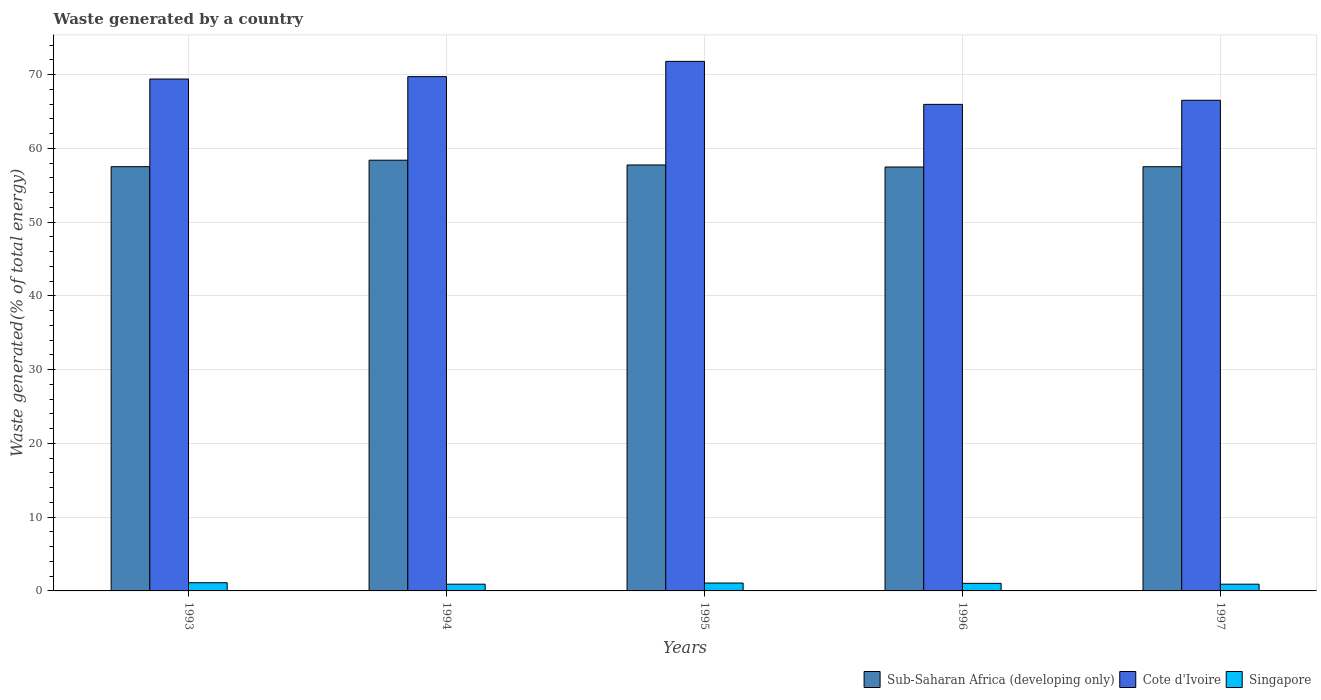How many different coloured bars are there?
Provide a succinct answer. 3. Are the number of bars per tick equal to the number of legend labels?
Offer a terse response. Yes. Are the number of bars on each tick of the X-axis equal?
Provide a succinct answer. Yes. In how many cases, is the number of bars for a given year not equal to the number of legend labels?
Offer a terse response. 0. What is the total waste generated in Singapore in 1997?
Provide a succinct answer. 0.91. Across all years, what is the maximum total waste generated in Sub-Saharan Africa (developing only)?
Offer a terse response. 58.41. Across all years, what is the minimum total waste generated in Singapore?
Your answer should be very brief. 0.91. In which year was the total waste generated in Sub-Saharan Africa (developing only) maximum?
Your response must be concise. 1994. What is the total total waste generated in Sub-Saharan Africa (developing only) in the graph?
Provide a succinct answer. 288.73. What is the difference between the total waste generated in Sub-Saharan Africa (developing only) in 1995 and that in 1996?
Your response must be concise. 0.28. What is the difference between the total waste generated in Cote d'Ivoire in 1993 and the total waste generated in Singapore in 1994?
Ensure brevity in your answer.  68.51. What is the average total waste generated in Sub-Saharan Africa (developing only) per year?
Provide a short and direct response. 57.75. In the year 1995, what is the difference between the total waste generated in Singapore and total waste generated in Cote d'Ivoire?
Your answer should be very brief. -70.74. What is the ratio of the total waste generated in Cote d'Ivoire in 1994 to that in 1997?
Make the answer very short. 1.05. Is the total waste generated in Singapore in 1993 less than that in 1994?
Provide a succinct answer. No. Is the difference between the total waste generated in Singapore in 1995 and 1996 greater than the difference between the total waste generated in Cote d'Ivoire in 1995 and 1996?
Keep it short and to the point. No. What is the difference between the highest and the second highest total waste generated in Singapore?
Your answer should be compact. 0.04. What is the difference between the highest and the lowest total waste generated in Sub-Saharan Africa (developing only)?
Your answer should be very brief. 0.92. In how many years, is the total waste generated in Singapore greater than the average total waste generated in Singapore taken over all years?
Keep it short and to the point. 3. What does the 1st bar from the left in 1994 represents?
Offer a terse response. Sub-Saharan Africa (developing only). What does the 2nd bar from the right in 1993 represents?
Give a very brief answer. Cote d'Ivoire. Are all the bars in the graph horizontal?
Offer a terse response. No. How many years are there in the graph?
Your response must be concise. 5. Are the values on the major ticks of Y-axis written in scientific E-notation?
Make the answer very short. No. Does the graph contain any zero values?
Provide a short and direct response. No. How many legend labels are there?
Make the answer very short. 3. How are the legend labels stacked?
Ensure brevity in your answer.  Horizontal. What is the title of the graph?
Offer a very short reply. Waste generated by a country. What is the label or title of the Y-axis?
Ensure brevity in your answer.  Waste generated(% of total energy). What is the Waste generated(% of total energy) in Sub-Saharan Africa (developing only) in 1993?
Offer a terse response. 57.53. What is the Waste generated(% of total energy) of Cote d'Ivoire in 1993?
Provide a short and direct response. 69.42. What is the Waste generated(% of total energy) in Singapore in 1993?
Your answer should be compact. 1.11. What is the Waste generated(% of total energy) in Sub-Saharan Africa (developing only) in 1994?
Give a very brief answer. 58.41. What is the Waste generated(% of total energy) in Cote d'Ivoire in 1994?
Your answer should be compact. 69.75. What is the Waste generated(% of total energy) of Singapore in 1994?
Ensure brevity in your answer.  0.91. What is the Waste generated(% of total energy) in Sub-Saharan Africa (developing only) in 1995?
Give a very brief answer. 57.77. What is the Waste generated(% of total energy) of Cote d'Ivoire in 1995?
Your answer should be compact. 71.82. What is the Waste generated(% of total energy) in Singapore in 1995?
Your response must be concise. 1.07. What is the Waste generated(% of total energy) in Sub-Saharan Africa (developing only) in 1996?
Your answer should be compact. 57.49. What is the Waste generated(% of total energy) of Cote d'Ivoire in 1996?
Offer a very short reply. 65.98. What is the Waste generated(% of total energy) of Singapore in 1996?
Give a very brief answer. 1.03. What is the Waste generated(% of total energy) of Sub-Saharan Africa (developing only) in 1997?
Offer a terse response. 57.53. What is the Waste generated(% of total energy) of Cote d'Ivoire in 1997?
Keep it short and to the point. 66.54. What is the Waste generated(% of total energy) in Singapore in 1997?
Make the answer very short. 0.91. Across all years, what is the maximum Waste generated(% of total energy) of Sub-Saharan Africa (developing only)?
Ensure brevity in your answer.  58.41. Across all years, what is the maximum Waste generated(% of total energy) of Cote d'Ivoire?
Ensure brevity in your answer.  71.82. Across all years, what is the maximum Waste generated(% of total energy) in Singapore?
Provide a short and direct response. 1.11. Across all years, what is the minimum Waste generated(% of total energy) of Sub-Saharan Africa (developing only)?
Provide a short and direct response. 57.49. Across all years, what is the minimum Waste generated(% of total energy) in Cote d'Ivoire?
Your answer should be compact. 65.98. Across all years, what is the minimum Waste generated(% of total energy) in Singapore?
Make the answer very short. 0.91. What is the total Waste generated(% of total energy) of Sub-Saharan Africa (developing only) in the graph?
Your answer should be very brief. 288.73. What is the total Waste generated(% of total energy) in Cote d'Ivoire in the graph?
Your answer should be very brief. 343.51. What is the total Waste generated(% of total energy) in Singapore in the graph?
Provide a short and direct response. 5.04. What is the difference between the Waste generated(% of total energy) in Sub-Saharan Africa (developing only) in 1993 and that in 1994?
Your answer should be compact. -0.88. What is the difference between the Waste generated(% of total energy) in Cote d'Ivoire in 1993 and that in 1994?
Provide a short and direct response. -0.33. What is the difference between the Waste generated(% of total energy) of Singapore in 1993 and that in 1994?
Provide a succinct answer. 0.2. What is the difference between the Waste generated(% of total energy) in Sub-Saharan Africa (developing only) in 1993 and that in 1995?
Keep it short and to the point. -0.23. What is the difference between the Waste generated(% of total energy) in Cote d'Ivoire in 1993 and that in 1995?
Offer a very short reply. -2.4. What is the difference between the Waste generated(% of total energy) of Singapore in 1993 and that in 1995?
Your response must be concise. 0.04. What is the difference between the Waste generated(% of total energy) in Sub-Saharan Africa (developing only) in 1993 and that in 1996?
Your answer should be very brief. 0.05. What is the difference between the Waste generated(% of total energy) of Cote d'Ivoire in 1993 and that in 1996?
Your answer should be compact. 3.44. What is the difference between the Waste generated(% of total energy) in Singapore in 1993 and that in 1996?
Ensure brevity in your answer.  0.08. What is the difference between the Waste generated(% of total energy) in Sub-Saharan Africa (developing only) in 1993 and that in 1997?
Offer a terse response. 0.01. What is the difference between the Waste generated(% of total energy) of Cote d'Ivoire in 1993 and that in 1997?
Provide a succinct answer. 2.88. What is the difference between the Waste generated(% of total energy) in Singapore in 1993 and that in 1997?
Provide a succinct answer. 0.2. What is the difference between the Waste generated(% of total energy) in Sub-Saharan Africa (developing only) in 1994 and that in 1995?
Keep it short and to the point. 0.65. What is the difference between the Waste generated(% of total energy) in Cote d'Ivoire in 1994 and that in 1995?
Provide a succinct answer. -2.07. What is the difference between the Waste generated(% of total energy) in Singapore in 1994 and that in 1995?
Provide a short and direct response. -0.16. What is the difference between the Waste generated(% of total energy) in Sub-Saharan Africa (developing only) in 1994 and that in 1996?
Make the answer very short. 0.92. What is the difference between the Waste generated(% of total energy) of Cote d'Ivoire in 1994 and that in 1996?
Provide a succinct answer. 3.76. What is the difference between the Waste generated(% of total energy) of Singapore in 1994 and that in 1996?
Your response must be concise. -0.11. What is the difference between the Waste generated(% of total energy) of Sub-Saharan Africa (developing only) in 1994 and that in 1997?
Make the answer very short. 0.88. What is the difference between the Waste generated(% of total energy) in Cote d'Ivoire in 1994 and that in 1997?
Your answer should be compact. 3.21. What is the difference between the Waste generated(% of total energy) of Singapore in 1994 and that in 1997?
Offer a terse response. -0. What is the difference between the Waste generated(% of total energy) in Sub-Saharan Africa (developing only) in 1995 and that in 1996?
Your response must be concise. 0.28. What is the difference between the Waste generated(% of total energy) of Cote d'Ivoire in 1995 and that in 1996?
Make the answer very short. 5.83. What is the difference between the Waste generated(% of total energy) in Singapore in 1995 and that in 1996?
Provide a succinct answer. 0.04. What is the difference between the Waste generated(% of total energy) in Sub-Saharan Africa (developing only) in 1995 and that in 1997?
Keep it short and to the point. 0.24. What is the difference between the Waste generated(% of total energy) in Cote d'Ivoire in 1995 and that in 1997?
Ensure brevity in your answer.  5.28. What is the difference between the Waste generated(% of total energy) of Singapore in 1995 and that in 1997?
Offer a terse response. 0.16. What is the difference between the Waste generated(% of total energy) of Sub-Saharan Africa (developing only) in 1996 and that in 1997?
Ensure brevity in your answer.  -0.04. What is the difference between the Waste generated(% of total energy) of Cote d'Ivoire in 1996 and that in 1997?
Ensure brevity in your answer.  -0.56. What is the difference between the Waste generated(% of total energy) of Singapore in 1996 and that in 1997?
Your response must be concise. 0.11. What is the difference between the Waste generated(% of total energy) in Sub-Saharan Africa (developing only) in 1993 and the Waste generated(% of total energy) in Cote d'Ivoire in 1994?
Your answer should be compact. -12.21. What is the difference between the Waste generated(% of total energy) of Sub-Saharan Africa (developing only) in 1993 and the Waste generated(% of total energy) of Singapore in 1994?
Your answer should be very brief. 56.62. What is the difference between the Waste generated(% of total energy) of Cote d'Ivoire in 1993 and the Waste generated(% of total energy) of Singapore in 1994?
Make the answer very short. 68.51. What is the difference between the Waste generated(% of total energy) of Sub-Saharan Africa (developing only) in 1993 and the Waste generated(% of total energy) of Cote d'Ivoire in 1995?
Provide a succinct answer. -14.28. What is the difference between the Waste generated(% of total energy) in Sub-Saharan Africa (developing only) in 1993 and the Waste generated(% of total energy) in Singapore in 1995?
Your response must be concise. 56.46. What is the difference between the Waste generated(% of total energy) in Cote d'Ivoire in 1993 and the Waste generated(% of total energy) in Singapore in 1995?
Offer a terse response. 68.35. What is the difference between the Waste generated(% of total energy) of Sub-Saharan Africa (developing only) in 1993 and the Waste generated(% of total energy) of Cote d'Ivoire in 1996?
Keep it short and to the point. -8.45. What is the difference between the Waste generated(% of total energy) in Sub-Saharan Africa (developing only) in 1993 and the Waste generated(% of total energy) in Singapore in 1996?
Your response must be concise. 56.51. What is the difference between the Waste generated(% of total energy) of Cote d'Ivoire in 1993 and the Waste generated(% of total energy) of Singapore in 1996?
Your answer should be very brief. 68.39. What is the difference between the Waste generated(% of total energy) in Sub-Saharan Africa (developing only) in 1993 and the Waste generated(% of total energy) in Cote d'Ivoire in 1997?
Your answer should be very brief. -9.01. What is the difference between the Waste generated(% of total energy) in Sub-Saharan Africa (developing only) in 1993 and the Waste generated(% of total energy) in Singapore in 1997?
Offer a very short reply. 56.62. What is the difference between the Waste generated(% of total energy) in Cote d'Ivoire in 1993 and the Waste generated(% of total energy) in Singapore in 1997?
Provide a succinct answer. 68.51. What is the difference between the Waste generated(% of total energy) of Sub-Saharan Africa (developing only) in 1994 and the Waste generated(% of total energy) of Cote d'Ivoire in 1995?
Provide a short and direct response. -13.4. What is the difference between the Waste generated(% of total energy) in Sub-Saharan Africa (developing only) in 1994 and the Waste generated(% of total energy) in Singapore in 1995?
Give a very brief answer. 57.34. What is the difference between the Waste generated(% of total energy) of Cote d'Ivoire in 1994 and the Waste generated(% of total energy) of Singapore in 1995?
Your answer should be compact. 68.67. What is the difference between the Waste generated(% of total energy) in Sub-Saharan Africa (developing only) in 1994 and the Waste generated(% of total energy) in Cote d'Ivoire in 1996?
Ensure brevity in your answer.  -7.57. What is the difference between the Waste generated(% of total energy) in Sub-Saharan Africa (developing only) in 1994 and the Waste generated(% of total energy) in Singapore in 1996?
Give a very brief answer. 57.38. What is the difference between the Waste generated(% of total energy) of Cote d'Ivoire in 1994 and the Waste generated(% of total energy) of Singapore in 1996?
Provide a short and direct response. 68.72. What is the difference between the Waste generated(% of total energy) in Sub-Saharan Africa (developing only) in 1994 and the Waste generated(% of total energy) in Cote d'Ivoire in 1997?
Your answer should be compact. -8.13. What is the difference between the Waste generated(% of total energy) in Sub-Saharan Africa (developing only) in 1994 and the Waste generated(% of total energy) in Singapore in 1997?
Provide a short and direct response. 57.5. What is the difference between the Waste generated(% of total energy) of Cote d'Ivoire in 1994 and the Waste generated(% of total energy) of Singapore in 1997?
Your answer should be very brief. 68.83. What is the difference between the Waste generated(% of total energy) in Sub-Saharan Africa (developing only) in 1995 and the Waste generated(% of total energy) in Cote d'Ivoire in 1996?
Your answer should be compact. -8.22. What is the difference between the Waste generated(% of total energy) in Sub-Saharan Africa (developing only) in 1995 and the Waste generated(% of total energy) in Singapore in 1996?
Your answer should be very brief. 56.74. What is the difference between the Waste generated(% of total energy) in Cote d'Ivoire in 1995 and the Waste generated(% of total energy) in Singapore in 1996?
Keep it short and to the point. 70.79. What is the difference between the Waste generated(% of total energy) of Sub-Saharan Africa (developing only) in 1995 and the Waste generated(% of total energy) of Cote d'Ivoire in 1997?
Provide a succinct answer. -8.77. What is the difference between the Waste generated(% of total energy) of Sub-Saharan Africa (developing only) in 1995 and the Waste generated(% of total energy) of Singapore in 1997?
Offer a very short reply. 56.85. What is the difference between the Waste generated(% of total energy) of Cote d'Ivoire in 1995 and the Waste generated(% of total energy) of Singapore in 1997?
Keep it short and to the point. 70.9. What is the difference between the Waste generated(% of total energy) of Sub-Saharan Africa (developing only) in 1996 and the Waste generated(% of total energy) of Cote d'Ivoire in 1997?
Your answer should be very brief. -9.05. What is the difference between the Waste generated(% of total energy) of Sub-Saharan Africa (developing only) in 1996 and the Waste generated(% of total energy) of Singapore in 1997?
Give a very brief answer. 56.57. What is the difference between the Waste generated(% of total energy) in Cote d'Ivoire in 1996 and the Waste generated(% of total energy) in Singapore in 1997?
Ensure brevity in your answer.  65.07. What is the average Waste generated(% of total energy) in Sub-Saharan Africa (developing only) per year?
Your answer should be very brief. 57.75. What is the average Waste generated(% of total energy) in Cote d'Ivoire per year?
Provide a succinct answer. 68.7. What is the average Waste generated(% of total energy) of Singapore per year?
Keep it short and to the point. 1.01. In the year 1993, what is the difference between the Waste generated(% of total energy) of Sub-Saharan Africa (developing only) and Waste generated(% of total energy) of Cote d'Ivoire?
Your answer should be compact. -11.89. In the year 1993, what is the difference between the Waste generated(% of total energy) of Sub-Saharan Africa (developing only) and Waste generated(% of total energy) of Singapore?
Your answer should be very brief. 56.42. In the year 1993, what is the difference between the Waste generated(% of total energy) of Cote d'Ivoire and Waste generated(% of total energy) of Singapore?
Your answer should be very brief. 68.31. In the year 1994, what is the difference between the Waste generated(% of total energy) of Sub-Saharan Africa (developing only) and Waste generated(% of total energy) of Cote d'Ivoire?
Provide a succinct answer. -11.34. In the year 1994, what is the difference between the Waste generated(% of total energy) of Sub-Saharan Africa (developing only) and Waste generated(% of total energy) of Singapore?
Offer a very short reply. 57.5. In the year 1994, what is the difference between the Waste generated(% of total energy) of Cote d'Ivoire and Waste generated(% of total energy) of Singapore?
Provide a succinct answer. 68.83. In the year 1995, what is the difference between the Waste generated(% of total energy) of Sub-Saharan Africa (developing only) and Waste generated(% of total energy) of Cote d'Ivoire?
Offer a very short reply. -14.05. In the year 1995, what is the difference between the Waste generated(% of total energy) in Sub-Saharan Africa (developing only) and Waste generated(% of total energy) in Singapore?
Keep it short and to the point. 56.69. In the year 1995, what is the difference between the Waste generated(% of total energy) of Cote d'Ivoire and Waste generated(% of total energy) of Singapore?
Make the answer very short. 70.74. In the year 1996, what is the difference between the Waste generated(% of total energy) of Sub-Saharan Africa (developing only) and Waste generated(% of total energy) of Cote d'Ivoire?
Offer a very short reply. -8.49. In the year 1996, what is the difference between the Waste generated(% of total energy) in Sub-Saharan Africa (developing only) and Waste generated(% of total energy) in Singapore?
Provide a short and direct response. 56.46. In the year 1996, what is the difference between the Waste generated(% of total energy) of Cote d'Ivoire and Waste generated(% of total energy) of Singapore?
Provide a short and direct response. 64.96. In the year 1997, what is the difference between the Waste generated(% of total energy) of Sub-Saharan Africa (developing only) and Waste generated(% of total energy) of Cote d'Ivoire?
Offer a terse response. -9.01. In the year 1997, what is the difference between the Waste generated(% of total energy) of Sub-Saharan Africa (developing only) and Waste generated(% of total energy) of Singapore?
Your answer should be very brief. 56.61. In the year 1997, what is the difference between the Waste generated(% of total energy) in Cote d'Ivoire and Waste generated(% of total energy) in Singapore?
Provide a succinct answer. 65.63. What is the ratio of the Waste generated(% of total energy) in Sub-Saharan Africa (developing only) in 1993 to that in 1994?
Give a very brief answer. 0.98. What is the ratio of the Waste generated(% of total energy) in Singapore in 1993 to that in 1994?
Offer a very short reply. 1.21. What is the ratio of the Waste generated(% of total energy) of Cote d'Ivoire in 1993 to that in 1995?
Provide a short and direct response. 0.97. What is the ratio of the Waste generated(% of total energy) in Singapore in 1993 to that in 1995?
Make the answer very short. 1.04. What is the ratio of the Waste generated(% of total energy) of Cote d'Ivoire in 1993 to that in 1996?
Your response must be concise. 1.05. What is the ratio of the Waste generated(% of total energy) of Singapore in 1993 to that in 1996?
Your answer should be very brief. 1.08. What is the ratio of the Waste generated(% of total energy) in Cote d'Ivoire in 1993 to that in 1997?
Your answer should be compact. 1.04. What is the ratio of the Waste generated(% of total energy) of Singapore in 1993 to that in 1997?
Your answer should be compact. 1.21. What is the ratio of the Waste generated(% of total energy) in Sub-Saharan Africa (developing only) in 1994 to that in 1995?
Ensure brevity in your answer.  1.01. What is the ratio of the Waste generated(% of total energy) of Cote d'Ivoire in 1994 to that in 1995?
Ensure brevity in your answer.  0.97. What is the ratio of the Waste generated(% of total energy) in Singapore in 1994 to that in 1995?
Provide a short and direct response. 0.85. What is the ratio of the Waste generated(% of total energy) in Sub-Saharan Africa (developing only) in 1994 to that in 1996?
Offer a terse response. 1.02. What is the ratio of the Waste generated(% of total energy) of Cote d'Ivoire in 1994 to that in 1996?
Make the answer very short. 1.06. What is the ratio of the Waste generated(% of total energy) in Singapore in 1994 to that in 1996?
Your response must be concise. 0.89. What is the ratio of the Waste generated(% of total energy) in Sub-Saharan Africa (developing only) in 1994 to that in 1997?
Offer a terse response. 1.02. What is the ratio of the Waste generated(% of total energy) in Cote d'Ivoire in 1994 to that in 1997?
Give a very brief answer. 1.05. What is the ratio of the Waste generated(% of total energy) of Singapore in 1994 to that in 1997?
Provide a succinct answer. 1. What is the ratio of the Waste generated(% of total energy) of Sub-Saharan Africa (developing only) in 1995 to that in 1996?
Keep it short and to the point. 1. What is the ratio of the Waste generated(% of total energy) of Cote d'Ivoire in 1995 to that in 1996?
Your answer should be very brief. 1.09. What is the ratio of the Waste generated(% of total energy) in Singapore in 1995 to that in 1996?
Give a very brief answer. 1.04. What is the ratio of the Waste generated(% of total energy) of Sub-Saharan Africa (developing only) in 1995 to that in 1997?
Make the answer very short. 1. What is the ratio of the Waste generated(% of total energy) of Cote d'Ivoire in 1995 to that in 1997?
Give a very brief answer. 1.08. What is the ratio of the Waste generated(% of total energy) in Singapore in 1995 to that in 1997?
Provide a short and direct response. 1.17. What is the ratio of the Waste generated(% of total energy) of Cote d'Ivoire in 1996 to that in 1997?
Provide a short and direct response. 0.99. What is the ratio of the Waste generated(% of total energy) of Singapore in 1996 to that in 1997?
Provide a succinct answer. 1.12. What is the difference between the highest and the second highest Waste generated(% of total energy) of Sub-Saharan Africa (developing only)?
Your answer should be compact. 0.65. What is the difference between the highest and the second highest Waste generated(% of total energy) in Cote d'Ivoire?
Provide a short and direct response. 2.07. What is the difference between the highest and the second highest Waste generated(% of total energy) of Singapore?
Offer a very short reply. 0.04. What is the difference between the highest and the lowest Waste generated(% of total energy) of Sub-Saharan Africa (developing only)?
Provide a succinct answer. 0.92. What is the difference between the highest and the lowest Waste generated(% of total energy) of Cote d'Ivoire?
Make the answer very short. 5.83. What is the difference between the highest and the lowest Waste generated(% of total energy) in Singapore?
Offer a very short reply. 0.2. 